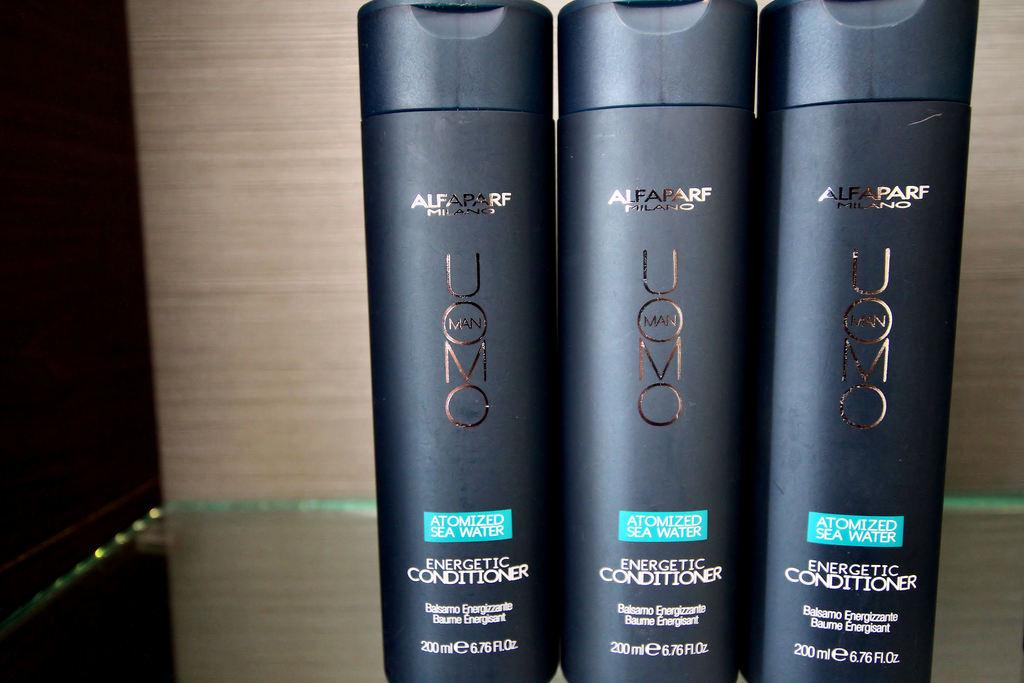<image>
Render a clear and concise summary of the photo. Three containers of Energetic Conditioner are lined up next to each other. 